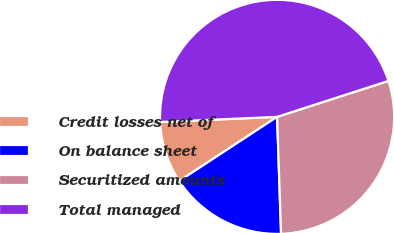Convert chart. <chart><loc_0><loc_0><loc_500><loc_500><pie_chart><fcel>Credit losses net of<fcel>On balance sheet<fcel>Securitized amounts<fcel>Total managed<nl><fcel>8.53%<fcel>16.31%<fcel>29.43%<fcel>45.74%<nl></chart> 